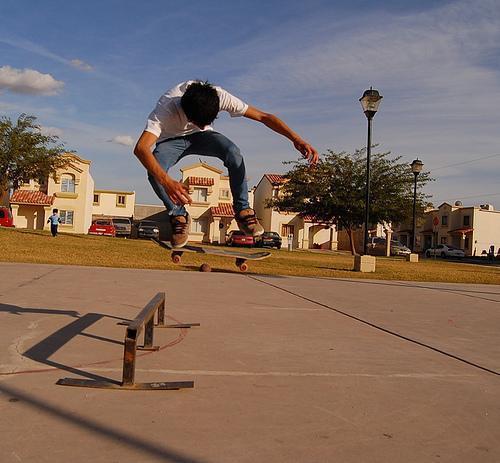How many people are there?
Give a very brief answer. 1. How many coca-cola bottles are there?
Give a very brief answer. 0. 